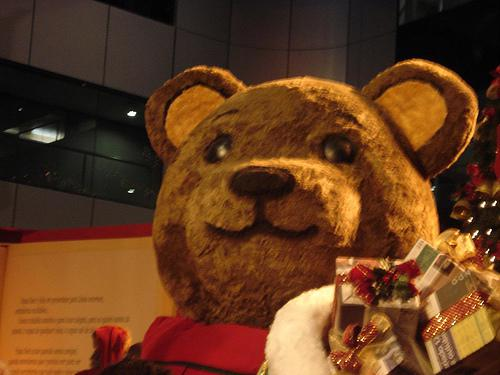Question: when was the photo taken?
Choices:
A. At Easter.
B. At Thanksgiving.
C. At Christmas time.
D. At New Year's.
Answer with the letter. Answer: C Question: what color is the bear?
Choices:
A. White.
B. Black.
C. Brown.
D. Gray.
Answer with the letter. Answer: C 